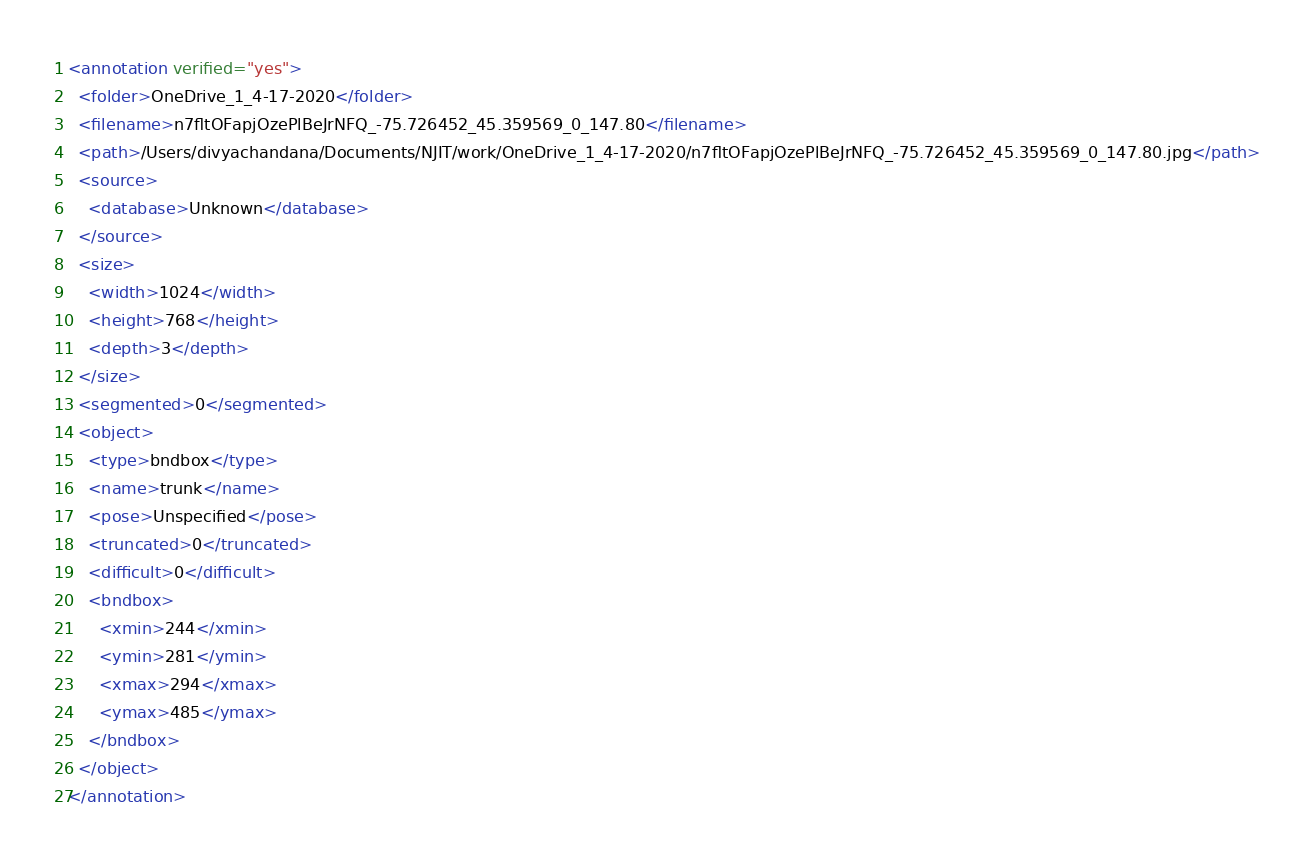<code> <loc_0><loc_0><loc_500><loc_500><_XML_><annotation verified="yes">
  <folder>OneDrive_1_4-17-2020</folder>
  <filename>n7fltOFapjOzePlBeJrNFQ_-75.726452_45.359569_0_147.80</filename>
  <path>/Users/divyachandana/Documents/NJIT/work/OneDrive_1_4-17-2020/n7fltOFapjOzePlBeJrNFQ_-75.726452_45.359569_0_147.80.jpg</path>
  <source>
    <database>Unknown</database>
  </source>
  <size>
    <width>1024</width>
    <height>768</height>
    <depth>3</depth>
  </size>
  <segmented>0</segmented>
  <object>
    <type>bndbox</type>
    <name>trunk</name>
    <pose>Unspecified</pose>
    <truncated>0</truncated>
    <difficult>0</difficult>
    <bndbox>
      <xmin>244</xmin>
      <ymin>281</ymin>
      <xmax>294</xmax>
      <ymax>485</ymax>
    </bndbox>
  </object>
</annotation>
</code> 